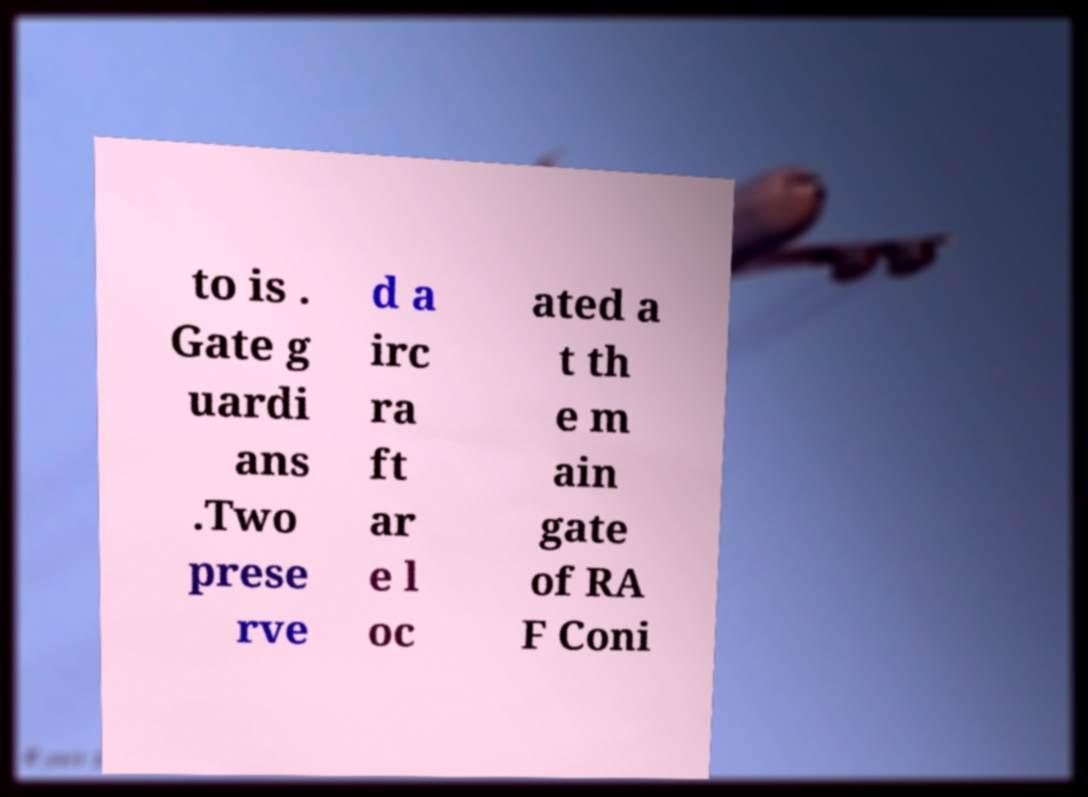Please identify and transcribe the text found in this image. to is . Gate g uardi ans .Two prese rve d a irc ra ft ar e l oc ated a t th e m ain gate of RA F Coni 